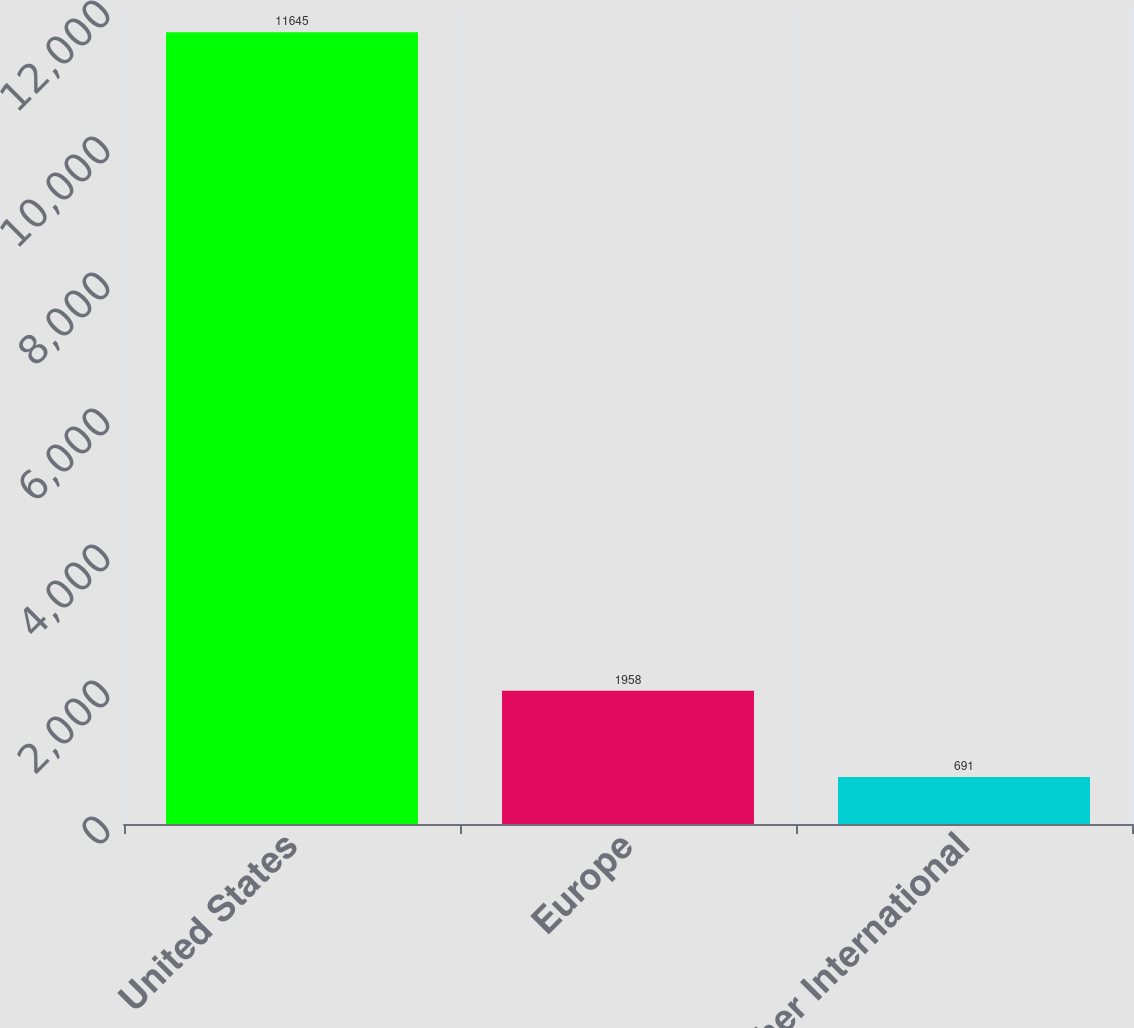Convert chart to OTSL. <chart><loc_0><loc_0><loc_500><loc_500><bar_chart><fcel>United States<fcel>Europe<fcel>Other International<nl><fcel>11645<fcel>1958<fcel>691<nl></chart> 